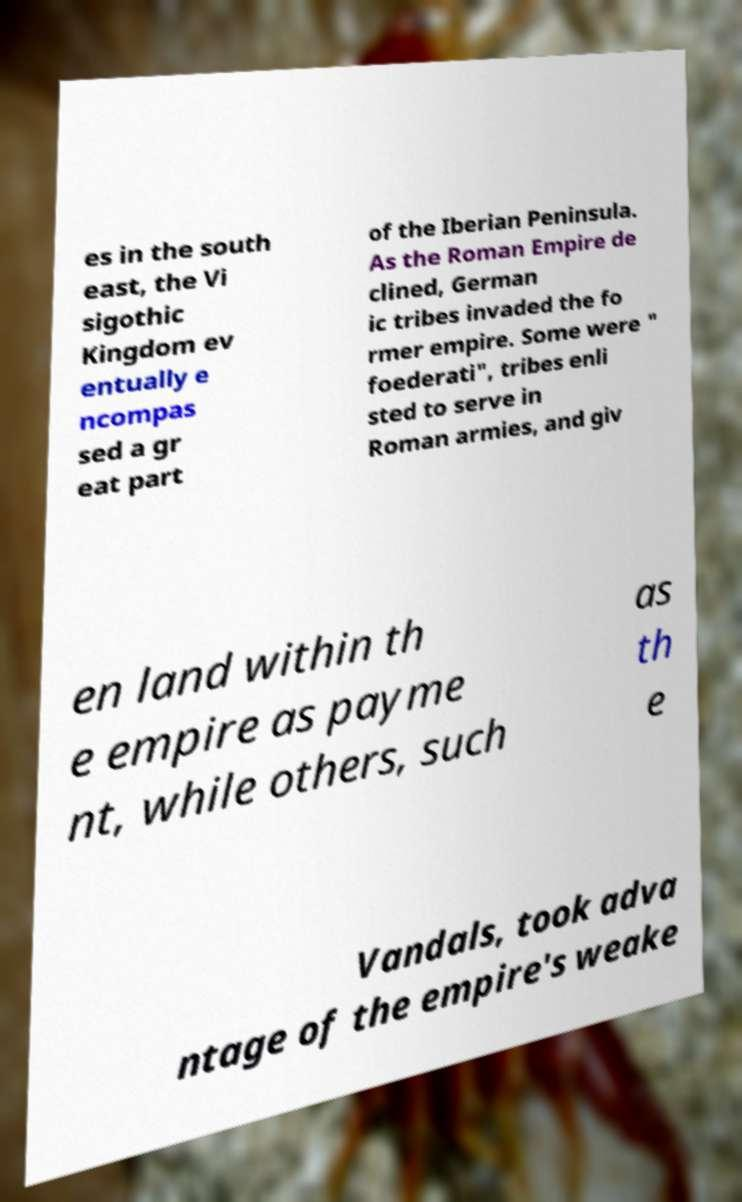I need the written content from this picture converted into text. Can you do that? es in the south east, the Vi sigothic Kingdom ev entually e ncompas sed a gr eat part of the Iberian Peninsula. As the Roman Empire de clined, German ic tribes invaded the fo rmer empire. Some were " foederati", tribes enli sted to serve in Roman armies, and giv en land within th e empire as payme nt, while others, such as th e Vandals, took adva ntage of the empire's weake 